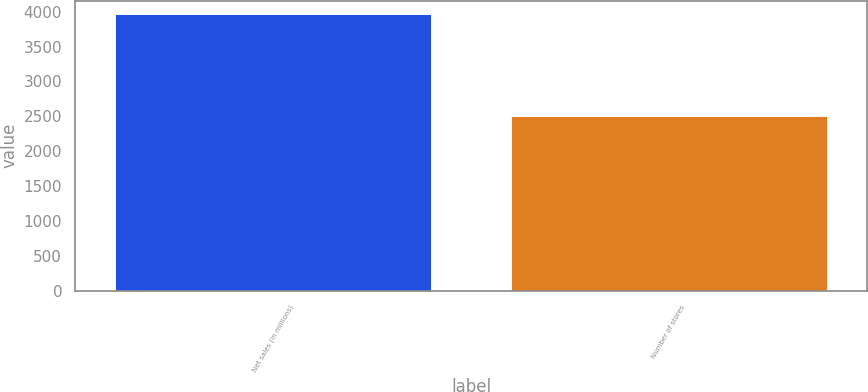Convert chart. <chart><loc_0><loc_0><loc_500><loc_500><bar_chart><fcel>Net sales (in millions)<fcel>Number of stores<nl><fcel>3962<fcel>2503<nl></chart> 